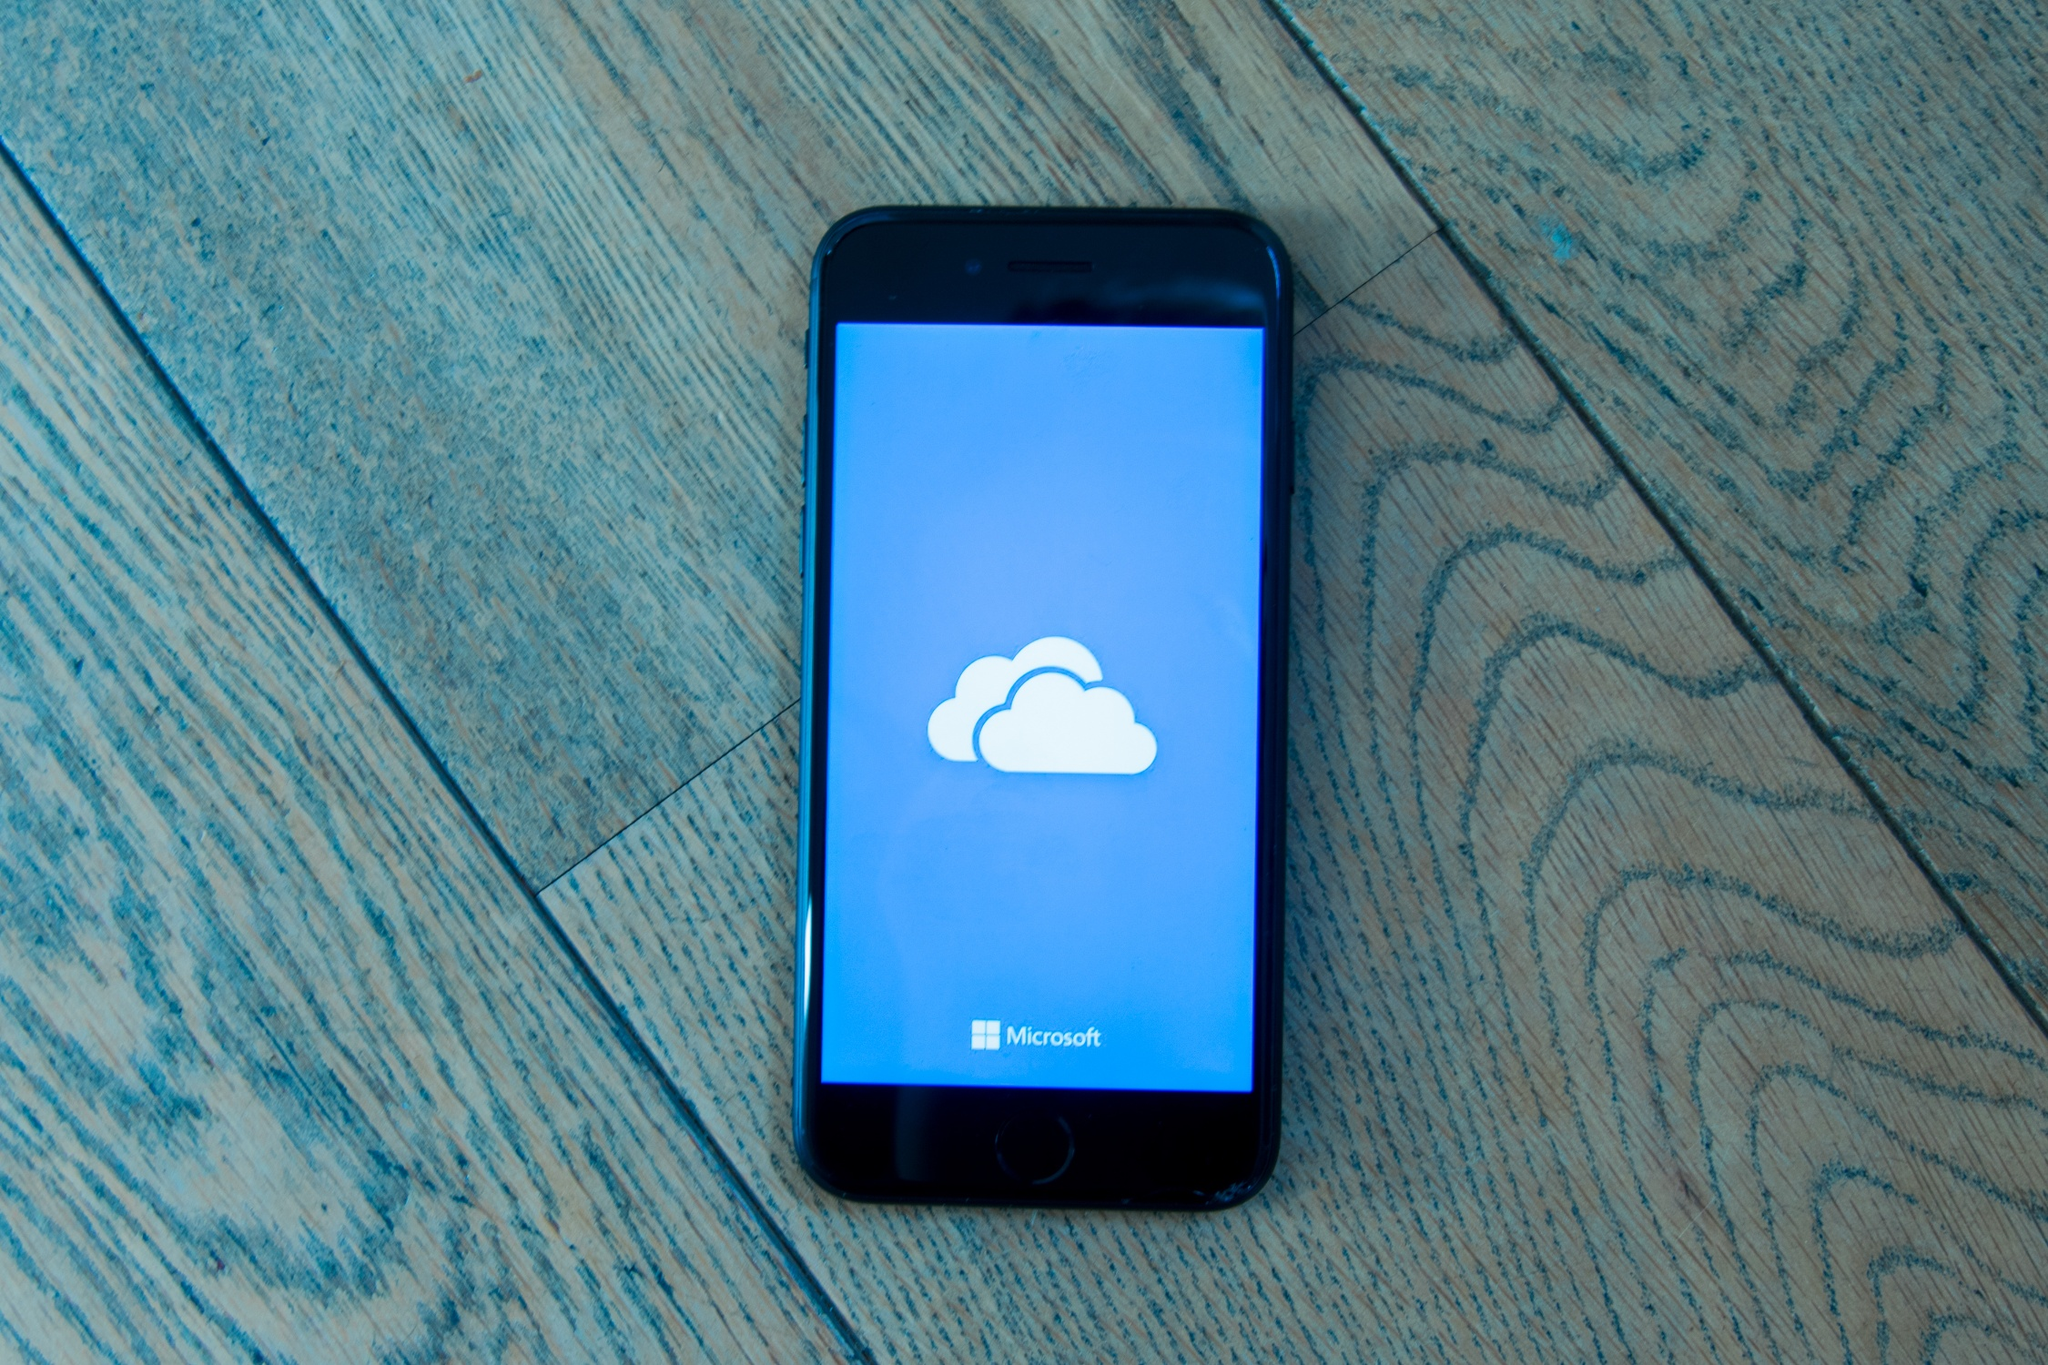What kind of technology might have been used to create this image, and what does it reveal about modern photography? This image appears to be crafted with attention to detail, likely using a high-quality digital camera or a modern smartphone with advanced camera capabilities. The clarity and sharpness of the iPhone screen, combined with the nuanced texture of the wooden floor, suggest the use of a device with excellent resolution and color accuracy. Additionally, the clean composition and precise focus highlight expertise in framing and possibly post-editing techniques. This reveals how modern photography increasingly relies on accessible technology, allowing even casual shots to achieve professional quality. It showcases the democratization of photography, where high-level results are no longer restricted to expensive equipment but also achievable through everyday devices and refined skills. Can you craft a futuristic scenario based on this image, pushing the boundaries of imagination? In a future world where humanity coexists with advanced AI beings, the iPhone on the floor is no ordinary device—it's a portal to other dimensions. The cloud icon on the screen represents 'Cloud Zero,' a collective consciousness where human thoughts and memories are stored, shared, and accessed in real-time. Ivy, a digital archaeologist, just stumbled upon an ancient thought relic embedded within Cloud Zero. As she navigates this relic with her iPhone, she unlocks forgotten knowledge about an advanced ancient civilization that once thrived on Earth before mysteriously vanishing. The wooden floor suddenly glows with intricate patterns as the iPhone scans and projects a hologram of the lost world's grandeur, blending reality with memory in a vivid tapestry of time. In this scenario, the image morphs into a gateway to past dimensions, intertwining human legacy with future technology. 